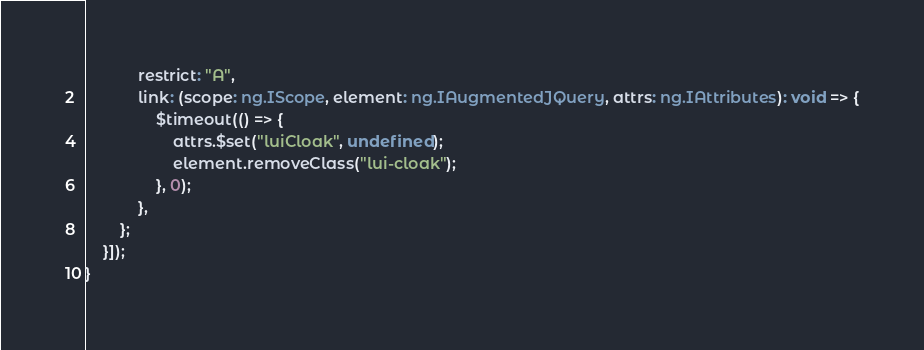<code> <loc_0><loc_0><loc_500><loc_500><_TypeScript_>			restrict: "A",
			link: (scope: ng.IScope, element: ng.IAugmentedJQuery, attrs: ng.IAttributes): void => {
				$timeout(() => {
					attrs.$set("luiCloak", undefined);
					element.removeClass("lui-cloak");
				}, 0);
			},
		};
	}]);
}
</code> 